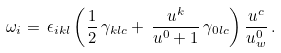<formula> <loc_0><loc_0><loc_500><loc_500>\omega _ { i } = \, \epsilon _ { i k l } \left ( \frac { 1 } { 2 } \, \gamma _ { k l c } + \, \frac { u ^ { k } } { u ^ { 0 } + 1 } \, \gamma _ { 0 l c } \right ) \frac { u ^ { c } } { u ^ { 0 } _ { w } } \, .</formula> 